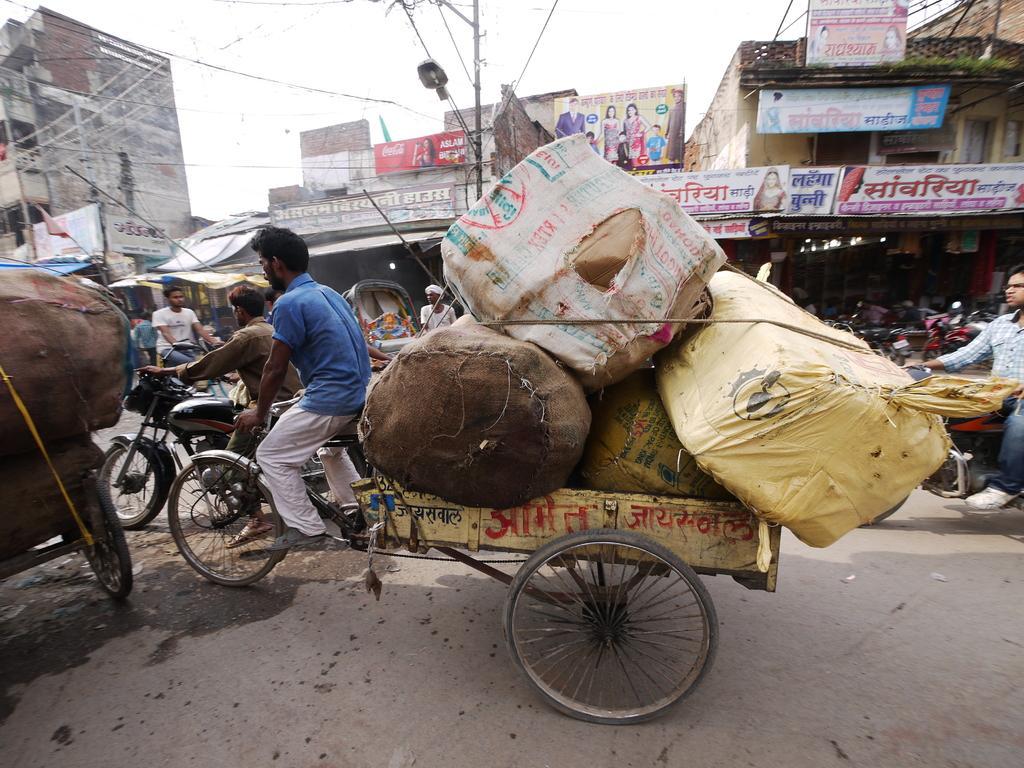In one or two sentences, can you explain what this image depicts? In the front of the image there are vehicles, people, carts, road and objects. In the background of the image there are buildings, boards, light pole, sky and objects. Something is written on the boards.   